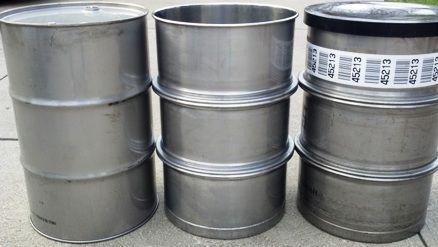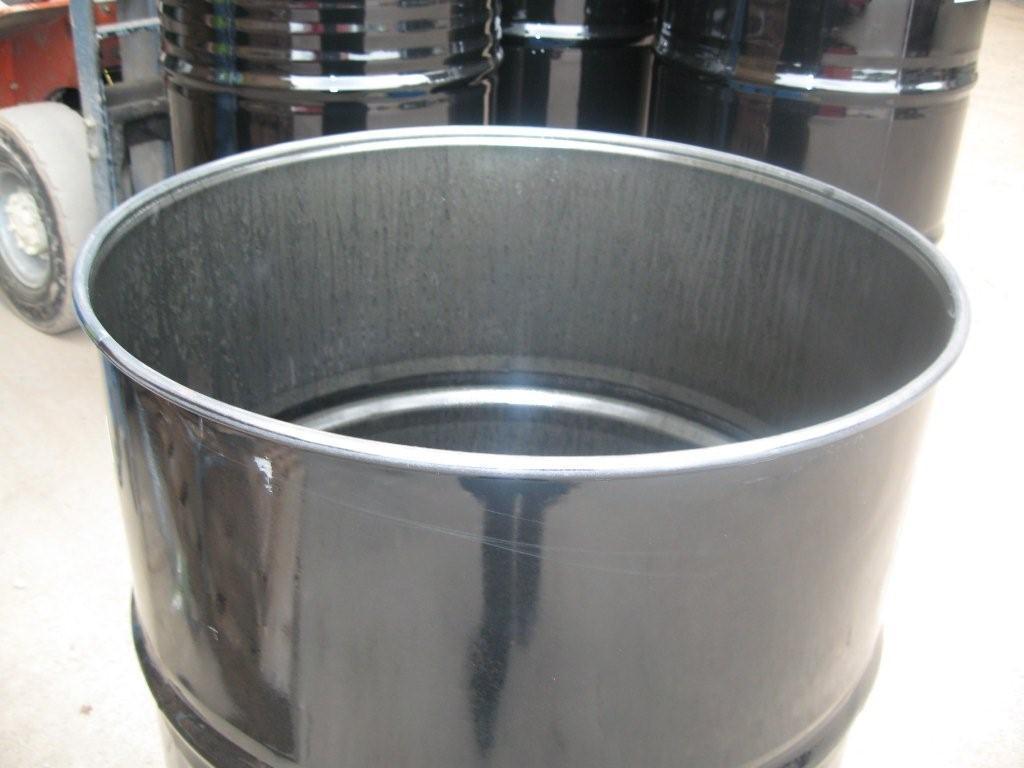The first image is the image on the left, the second image is the image on the right. Considering the images on both sides, is "There are more silver barrels in the image on the left than on the right." valid? Answer yes or no. Yes. The first image is the image on the left, the second image is the image on the right. Analyze the images presented: Is the assertion "All barrels are gray steel and some barrels have open tops." valid? Answer yes or no. Yes. 